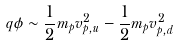<formula> <loc_0><loc_0><loc_500><loc_500>q \phi \sim \frac { 1 } { 2 } m _ { p } v _ { p , u } ^ { 2 } - \frac { 1 } { 2 } m _ { p } v _ { p , d } ^ { 2 }</formula> 